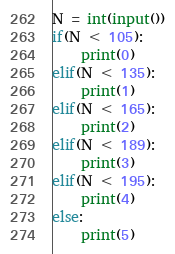<code> <loc_0><loc_0><loc_500><loc_500><_Python_>N = int(input())
if(N < 105):
	print(0)
elif(N < 135):
	print(1)
elif(N < 165):
	print(2)
elif(N < 189):
	print(3)
elif(N < 195):
	print(4)
else:
	print(5)</code> 